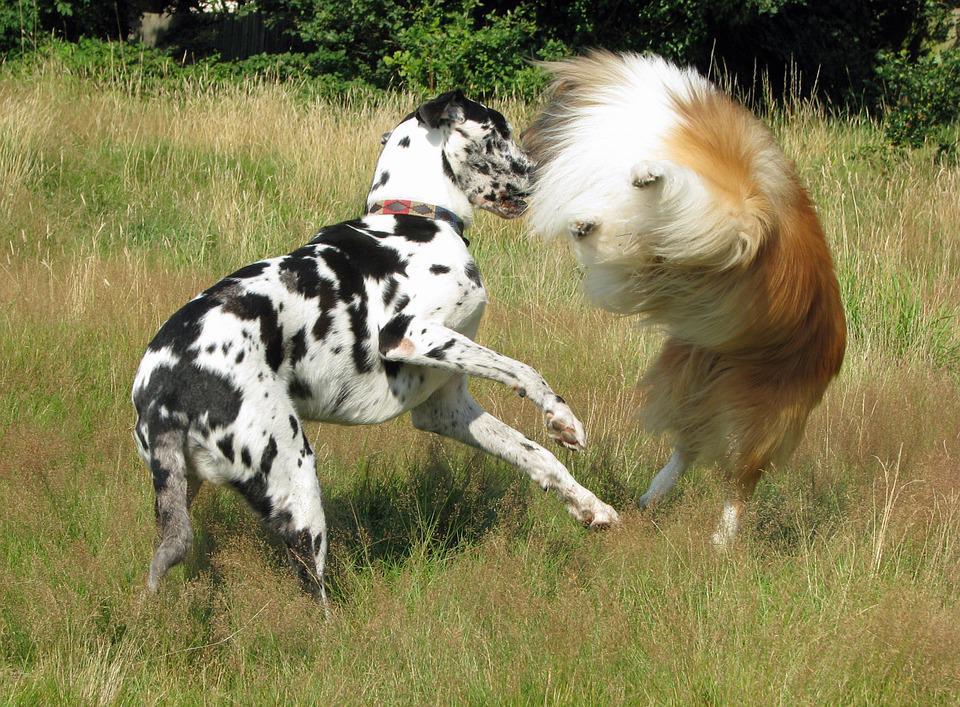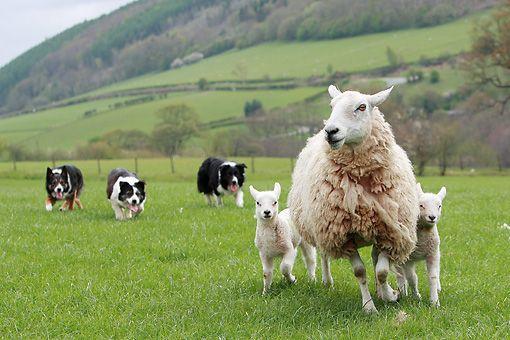The first image is the image on the left, the second image is the image on the right. Analyze the images presented: Is the assertion "One image has exactly three dogs." valid? Answer yes or no. Yes. 